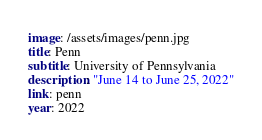Convert code to text. <code><loc_0><loc_0><loc_500><loc_500><_YAML_>image: /assets/images/penn.jpg
title: Penn
subtitle: University of Pennsylvania
description: "June 14 to June 25, 2022"
link: penn
year: 2022
</code> 